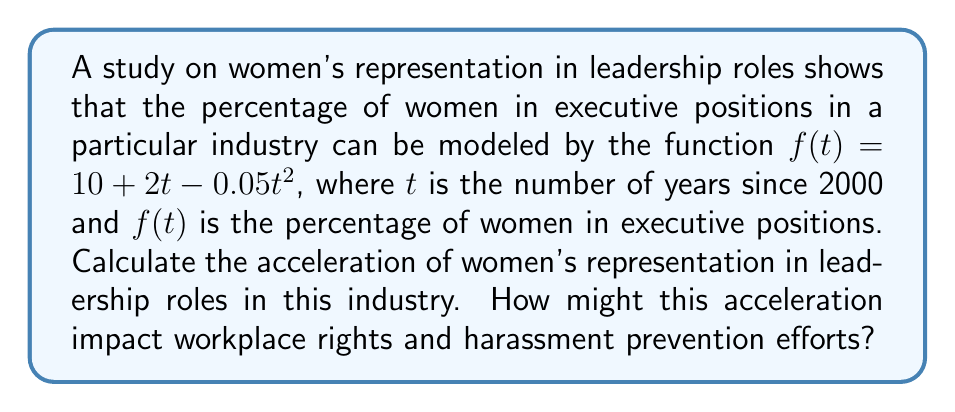Give your solution to this math problem. To analyze the acceleration of women's representation in leadership roles, we need to find the second derivative of the given function.

Step 1: Identify the original function.
$f(t) = 10 + 2t - 0.05t^2$

Step 2: Find the first derivative (velocity of change).
$$\frac{df}{dt} = 2 - 0.1t$$

Step 3: Find the second derivative (acceleration).
$$\frac{d^2f}{dt^2} = -0.1$$

The acceleration is constant and negative, indicating a deceleration in the rate of increase of women's representation in leadership roles.

Step 4: Interpret the result in the context of workplace rights and harassment prevention.
The negative acceleration (-0.1% per year squared) suggests that while the percentage of women in executive positions is still increasing (as long as the first derivative is positive), the rate of increase is slowing down over time. This deceleration could impact workplace rights and harassment prevention efforts in the following ways:

1. It may indicate a need for more robust policies and initiatives to maintain momentum in promoting women to leadership roles.
2. The slowing rate of increase could signal potential barriers or resistance to further progress, necessitating a reevaluation of current strategies for gender equality in the workplace.
3. As the rate of increase in women's representation slows, it may become more challenging to implement and enforce harassment prevention measures, as the diversity in leadership that often drives such initiatives may not be growing as quickly as desired.
4. The deceleration might suggest a need for more targeted legal frameworks to ensure continued progress in both women's representation and harassment prevention.
Answer: $-0.1$ (percentage points per year squared) 